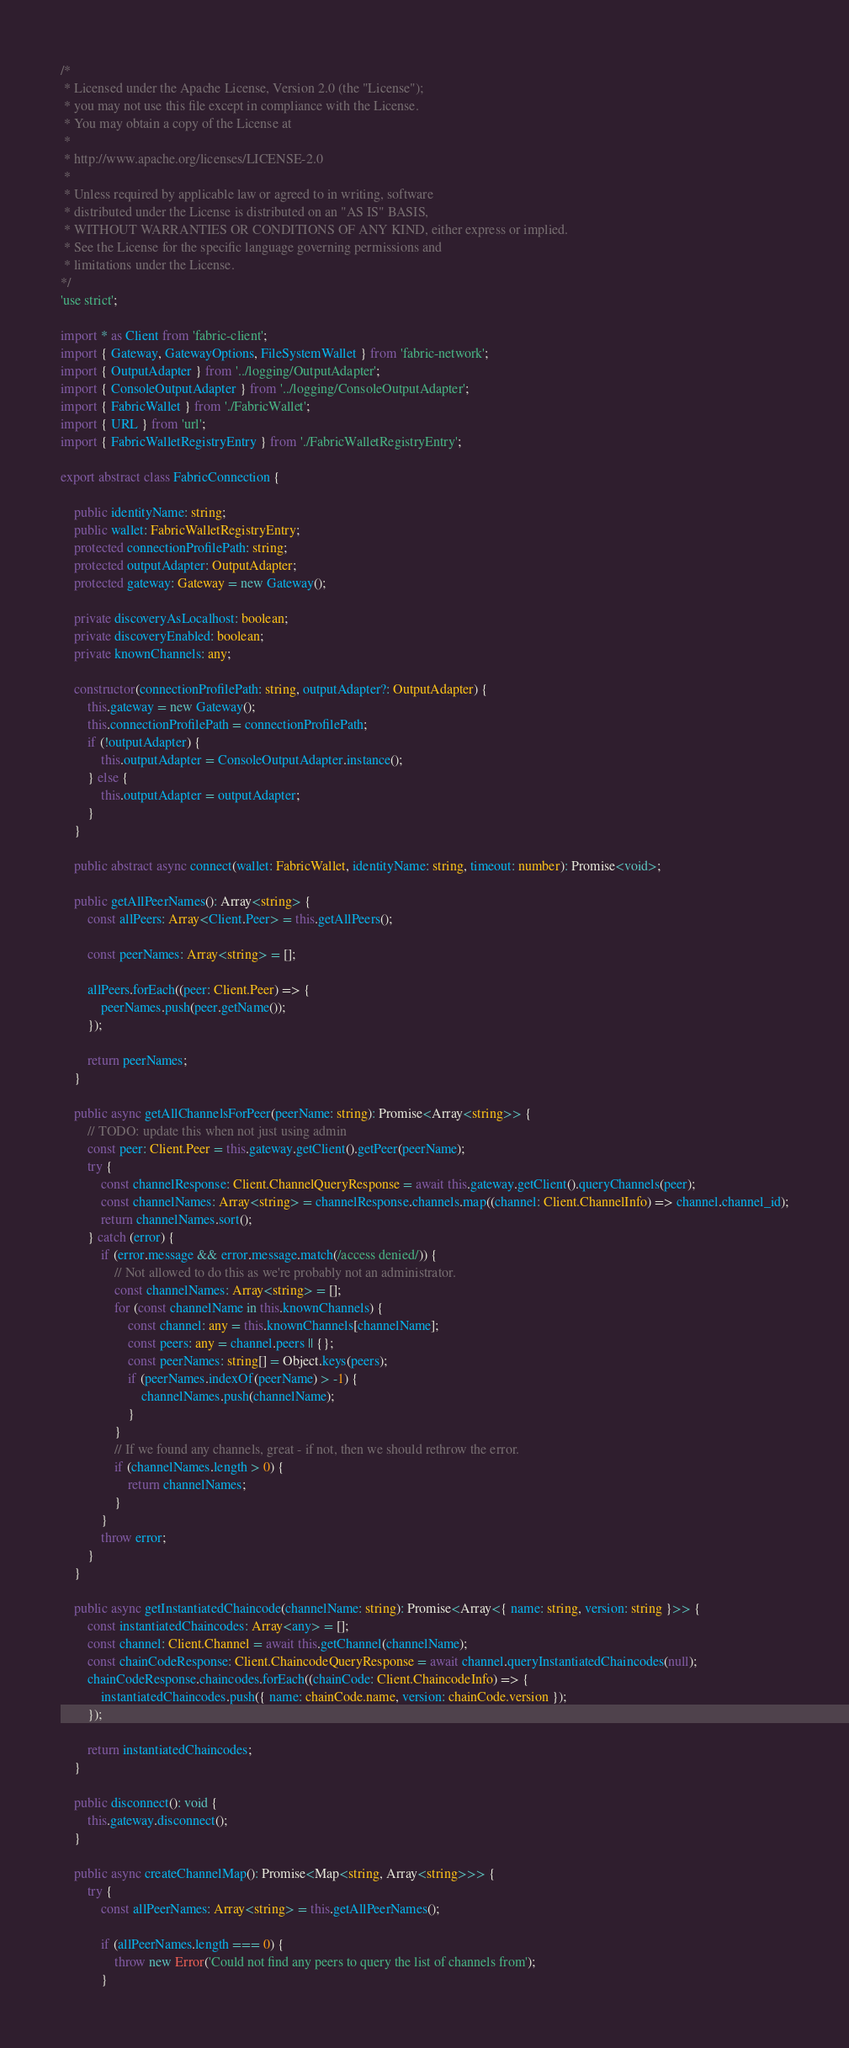<code> <loc_0><loc_0><loc_500><loc_500><_TypeScript_>/*
 * Licensed under the Apache License, Version 2.0 (the "License");
 * you may not use this file except in compliance with the License.
 * You may obtain a copy of the License at
 *
 * http://www.apache.org/licenses/LICENSE-2.0
 *
 * Unless required by applicable law or agreed to in writing, software
 * distributed under the License is distributed on an "AS IS" BASIS,
 * WITHOUT WARRANTIES OR CONDITIONS OF ANY KIND, either express or implied.
 * See the License for the specific language governing permissions and
 * limitations under the License.
*/
'use strict';

import * as Client from 'fabric-client';
import { Gateway, GatewayOptions, FileSystemWallet } from 'fabric-network';
import { OutputAdapter } from '../logging/OutputAdapter';
import { ConsoleOutputAdapter } from '../logging/ConsoleOutputAdapter';
import { FabricWallet } from './FabricWallet';
import { URL } from 'url';
import { FabricWalletRegistryEntry } from './FabricWalletRegistryEntry';

export abstract class FabricConnection {

    public identityName: string;
    public wallet: FabricWalletRegistryEntry;
    protected connectionProfilePath: string;
    protected outputAdapter: OutputAdapter;
    protected gateway: Gateway = new Gateway();

    private discoveryAsLocalhost: boolean;
    private discoveryEnabled: boolean;
    private knownChannels: any;

    constructor(connectionProfilePath: string, outputAdapter?: OutputAdapter) {
        this.gateway = new Gateway();
        this.connectionProfilePath = connectionProfilePath;
        if (!outputAdapter) {
            this.outputAdapter = ConsoleOutputAdapter.instance();
        } else {
            this.outputAdapter = outputAdapter;
        }
    }

    public abstract async connect(wallet: FabricWallet, identityName: string, timeout: number): Promise<void>;

    public getAllPeerNames(): Array<string> {
        const allPeers: Array<Client.Peer> = this.getAllPeers();

        const peerNames: Array<string> = [];

        allPeers.forEach((peer: Client.Peer) => {
            peerNames.push(peer.getName());
        });

        return peerNames;
    }

    public async getAllChannelsForPeer(peerName: string): Promise<Array<string>> {
        // TODO: update this when not just using admin
        const peer: Client.Peer = this.gateway.getClient().getPeer(peerName);
        try {
            const channelResponse: Client.ChannelQueryResponse = await this.gateway.getClient().queryChannels(peer);
            const channelNames: Array<string> = channelResponse.channels.map((channel: Client.ChannelInfo) => channel.channel_id);
            return channelNames.sort();
        } catch (error) {
            if (error.message && error.message.match(/access denied/)) {
                // Not allowed to do this as we're probably not an administrator.
                const channelNames: Array<string> = [];
                for (const channelName in this.knownChannels) {
                    const channel: any = this.knownChannels[channelName];
                    const peers: any = channel.peers || {};
                    const peerNames: string[] = Object.keys(peers);
                    if (peerNames.indexOf(peerName) > -1) {
                        channelNames.push(channelName);
                    }
                }
                // If we found any channels, great - if not, then we should rethrow the error.
                if (channelNames.length > 0) {
                    return channelNames;
                }
            }
            throw error;
        }
    }

    public async getInstantiatedChaincode(channelName: string): Promise<Array<{ name: string, version: string }>> {
        const instantiatedChaincodes: Array<any> = [];
        const channel: Client.Channel = await this.getChannel(channelName);
        const chainCodeResponse: Client.ChaincodeQueryResponse = await channel.queryInstantiatedChaincodes(null);
        chainCodeResponse.chaincodes.forEach((chainCode: Client.ChaincodeInfo) => {
            instantiatedChaincodes.push({ name: chainCode.name, version: chainCode.version });
        });

        return instantiatedChaincodes;
    }

    public disconnect(): void {
        this.gateway.disconnect();
    }

    public async createChannelMap(): Promise<Map<string, Array<string>>> {
        try {
            const allPeerNames: Array<string> = this.getAllPeerNames();

            if (allPeerNames.length === 0) {
                throw new Error('Could not find any peers to query the list of channels from');
            }
</code> 